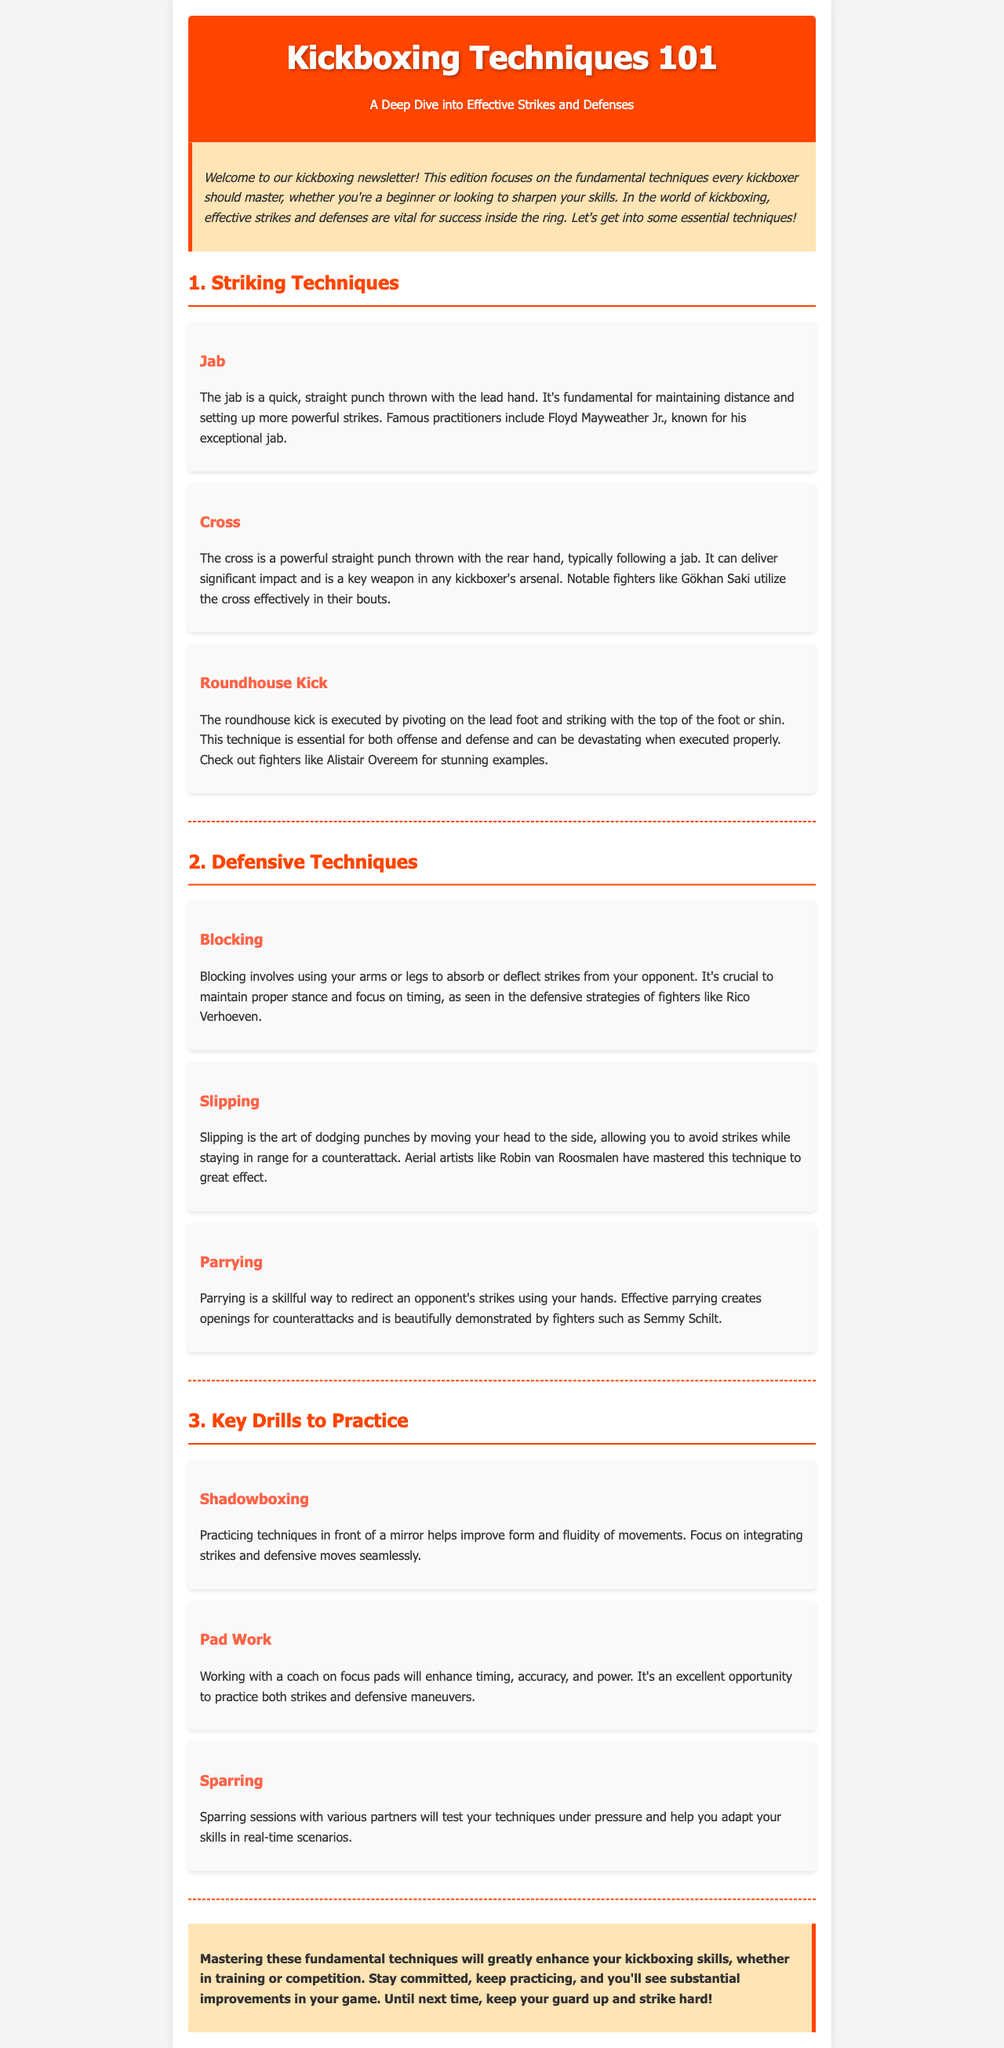What is the title of the newsletter? The title is presented prominently at the top of the document.
Answer: Kickboxing Techniques 101 Who is known for their exceptional jab? This information can be found in the section dedicated to striking techniques.
Answer: Floyd Mayweather Jr What type of kick is described as essential for both offense and defense? This information comes from the discussion about various striking techniques.
Answer: Roundhouse Kick Which defensive technique involves moving your head to the side? This technique is outlined under the defensive techniques section of the document.
Answer: Slipping What is one of the key drills mentioned for practicing? The document lists several drills for practice, one of which can be easily identified.
Answer: Shadowboxing Which kickboxer is associated with effective cross usage? The information can be inferred from the discussion on striking techniques and mentioned fighters.
Answer: Gökhan Saki What color is used for the header background? The header background color is described in the style section of the document.
Answer: Orange What is the main theme of this newsletter? The newsletter discusses techniques to enhance skills in kickboxing, which defines its main theme.
Answer: Effective Strikes and Defenses What should kickboxers keep doing to see improvements? This advice is mentioned in the conclusion at the end of the document.
Answer: Practicing 